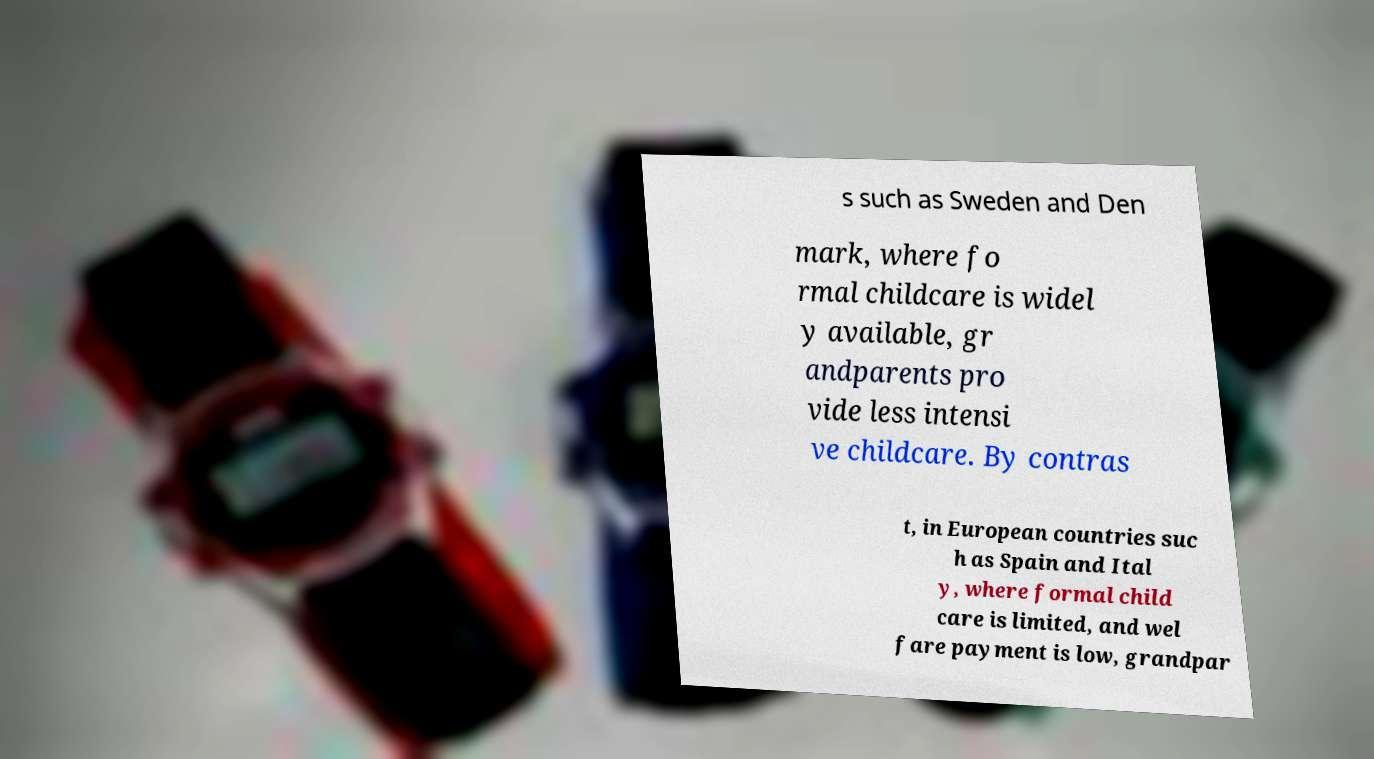What messages or text are displayed in this image? I need them in a readable, typed format. s such as Sweden and Den mark, where fo rmal childcare is widel y available, gr andparents pro vide less intensi ve childcare. By contras t, in European countries suc h as Spain and Ital y, where formal child care is limited, and wel fare payment is low, grandpar 